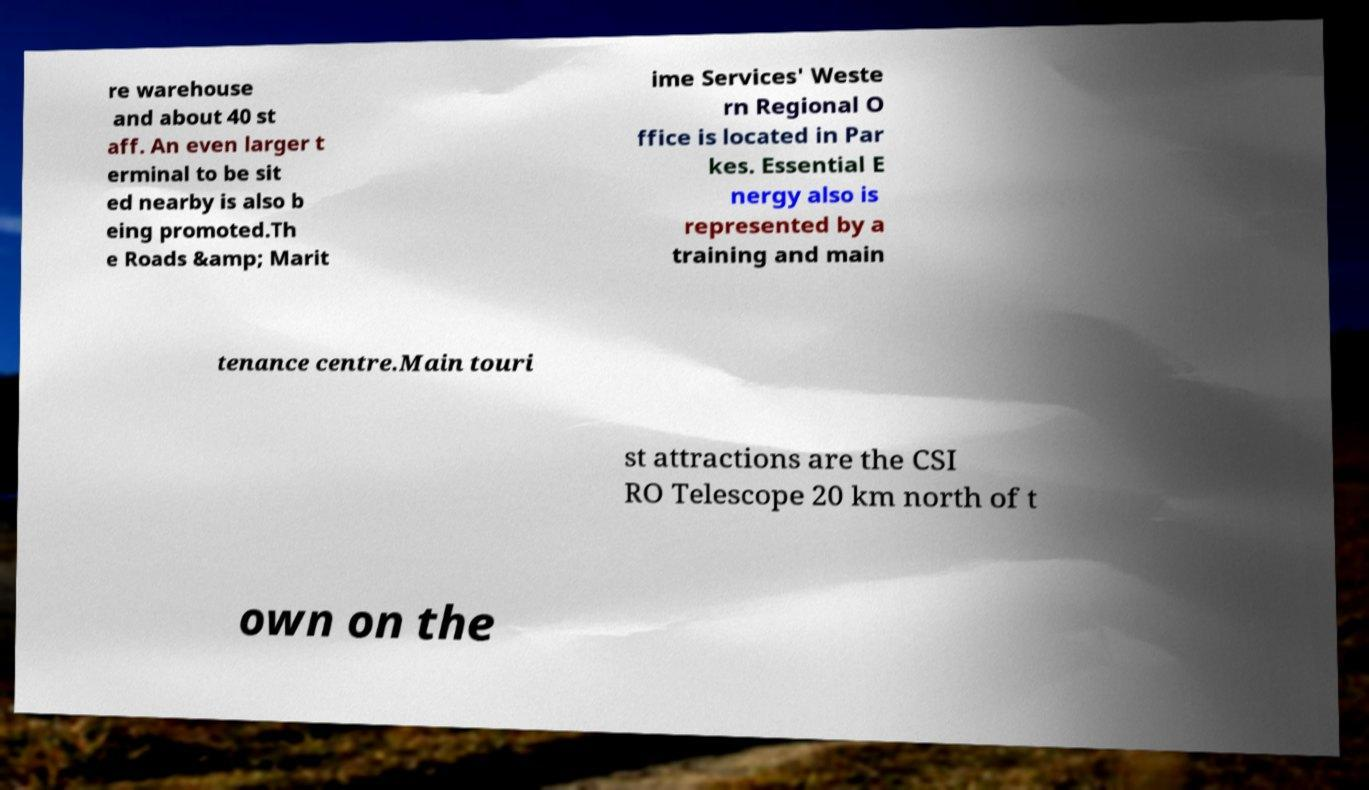Can you read and provide the text displayed in the image?This photo seems to have some interesting text. Can you extract and type it out for me? re warehouse and about 40 st aff. An even larger t erminal to be sit ed nearby is also b eing promoted.Th e Roads &amp; Marit ime Services' Weste rn Regional O ffice is located in Par kes. Essential E nergy also is represented by a training and main tenance centre.Main touri st attractions are the CSI RO Telescope 20 km north of t own on the 